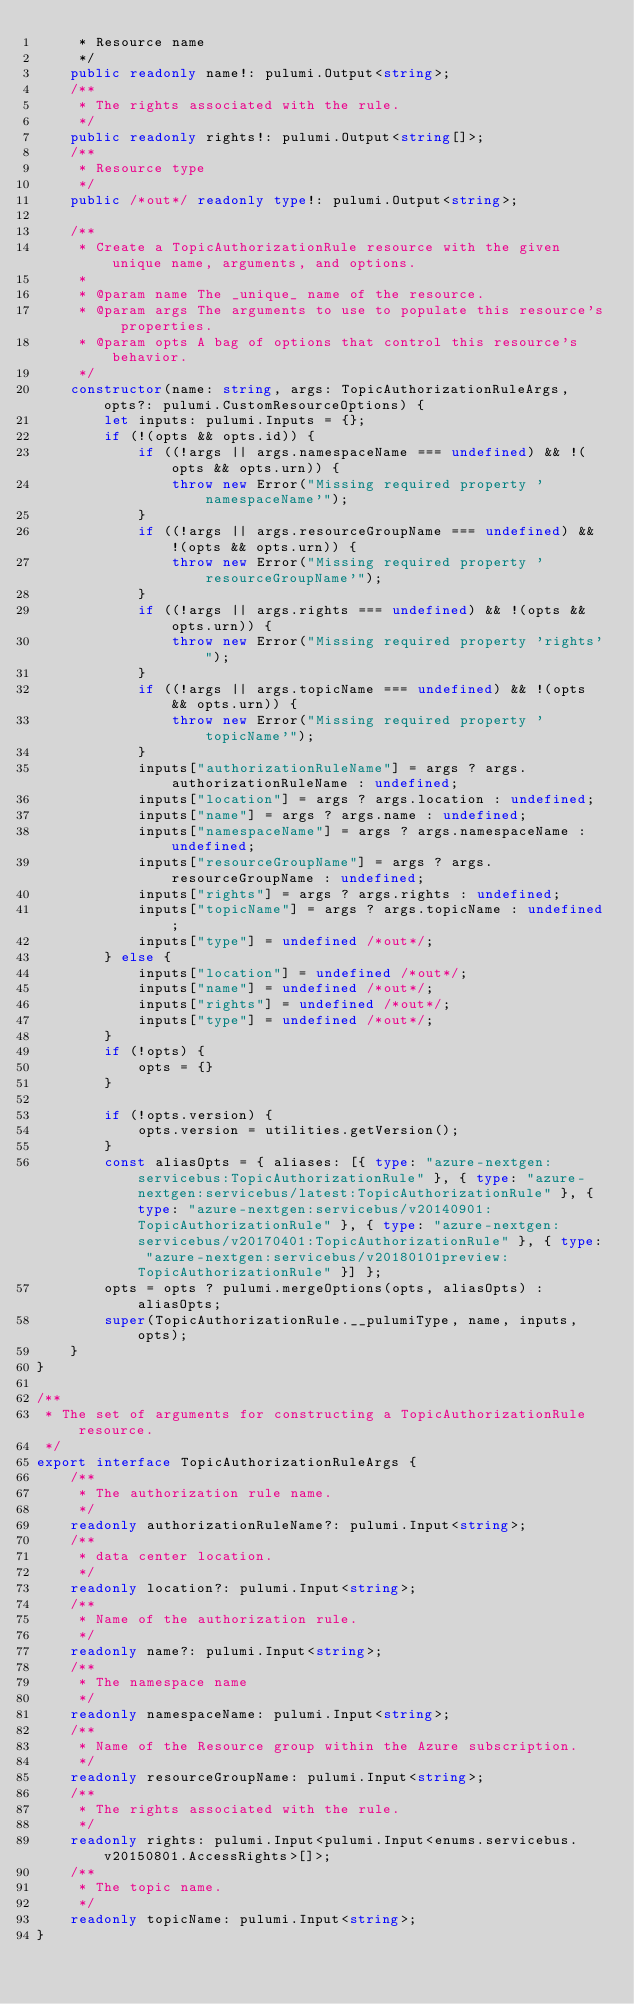<code> <loc_0><loc_0><loc_500><loc_500><_TypeScript_>     * Resource name
     */
    public readonly name!: pulumi.Output<string>;
    /**
     * The rights associated with the rule.
     */
    public readonly rights!: pulumi.Output<string[]>;
    /**
     * Resource type
     */
    public /*out*/ readonly type!: pulumi.Output<string>;

    /**
     * Create a TopicAuthorizationRule resource with the given unique name, arguments, and options.
     *
     * @param name The _unique_ name of the resource.
     * @param args The arguments to use to populate this resource's properties.
     * @param opts A bag of options that control this resource's behavior.
     */
    constructor(name: string, args: TopicAuthorizationRuleArgs, opts?: pulumi.CustomResourceOptions) {
        let inputs: pulumi.Inputs = {};
        if (!(opts && opts.id)) {
            if ((!args || args.namespaceName === undefined) && !(opts && opts.urn)) {
                throw new Error("Missing required property 'namespaceName'");
            }
            if ((!args || args.resourceGroupName === undefined) && !(opts && opts.urn)) {
                throw new Error("Missing required property 'resourceGroupName'");
            }
            if ((!args || args.rights === undefined) && !(opts && opts.urn)) {
                throw new Error("Missing required property 'rights'");
            }
            if ((!args || args.topicName === undefined) && !(opts && opts.urn)) {
                throw new Error("Missing required property 'topicName'");
            }
            inputs["authorizationRuleName"] = args ? args.authorizationRuleName : undefined;
            inputs["location"] = args ? args.location : undefined;
            inputs["name"] = args ? args.name : undefined;
            inputs["namespaceName"] = args ? args.namespaceName : undefined;
            inputs["resourceGroupName"] = args ? args.resourceGroupName : undefined;
            inputs["rights"] = args ? args.rights : undefined;
            inputs["topicName"] = args ? args.topicName : undefined;
            inputs["type"] = undefined /*out*/;
        } else {
            inputs["location"] = undefined /*out*/;
            inputs["name"] = undefined /*out*/;
            inputs["rights"] = undefined /*out*/;
            inputs["type"] = undefined /*out*/;
        }
        if (!opts) {
            opts = {}
        }

        if (!opts.version) {
            opts.version = utilities.getVersion();
        }
        const aliasOpts = { aliases: [{ type: "azure-nextgen:servicebus:TopicAuthorizationRule" }, { type: "azure-nextgen:servicebus/latest:TopicAuthorizationRule" }, { type: "azure-nextgen:servicebus/v20140901:TopicAuthorizationRule" }, { type: "azure-nextgen:servicebus/v20170401:TopicAuthorizationRule" }, { type: "azure-nextgen:servicebus/v20180101preview:TopicAuthorizationRule" }] };
        opts = opts ? pulumi.mergeOptions(opts, aliasOpts) : aliasOpts;
        super(TopicAuthorizationRule.__pulumiType, name, inputs, opts);
    }
}

/**
 * The set of arguments for constructing a TopicAuthorizationRule resource.
 */
export interface TopicAuthorizationRuleArgs {
    /**
     * The authorization rule name.
     */
    readonly authorizationRuleName?: pulumi.Input<string>;
    /**
     * data center location.
     */
    readonly location?: pulumi.Input<string>;
    /**
     * Name of the authorization rule.
     */
    readonly name?: pulumi.Input<string>;
    /**
     * The namespace name
     */
    readonly namespaceName: pulumi.Input<string>;
    /**
     * Name of the Resource group within the Azure subscription.
     */
    readonly resourceGroupName: pulumi.Input<string>;
    /**
     * The rights associated with the rule.
     */
    readonly rights: pulumi.Input<pulumi.Input<enums.servicebus.v20150801.AccessRights>[]>;
    /**
     * The topic name.
     */
    readonly topicName: pulumi.Input<string>;
}
</code> 